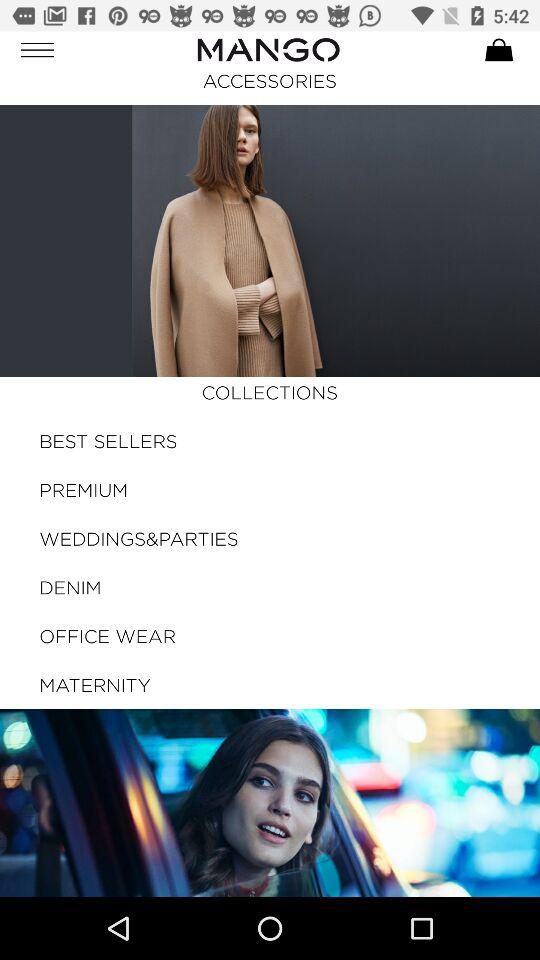What is the application name? The application name is "MANGO". 